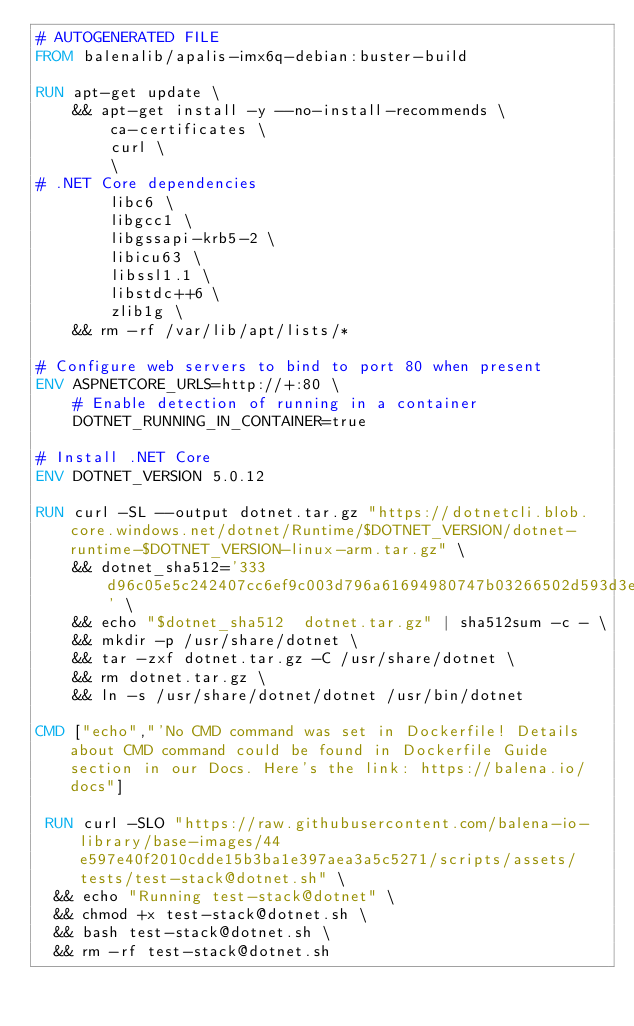Convert code to text. <code><loc_0><loc_0><loc_500><loc_500><_Dockerfile_># AUTOGENERATED FILE
FROM balenalib/apalis-imx6q-debian:buster-build

RUN apt-get update \
    && apt-get install -y --no-install-recommends \
        ca-certificates \
        curl \
        \
# .NET Core dependencies
        libc6 \
        libgcc1 \
        libgssapi-krb5-2 \
        libicu63 \
        libssl1.1 \
        libstdc++6 \
        zlib1g \
    && rm -rf /var/lib/apt/lists/*

# Configure web servers to bind to port 80 when present
ENV ASPNETCORE_URLS=http://+:80 \
    # Enable detection of running in a container
    DOTNET_RUNNING_IN_CONTAINER=true

# Install .NET Core
ENV DOTNET_VERSION 5.0.12

RUN curl -SL --output dotnet.tar.gz "https://dotnetcli.blob.core.windows.net/dotnet/Runtime/$DOTNET_VERSION/dotnet-runtime-$DOTNET_VERSION-linux-arm.tar.gz" \
    && dotnet_sha512='333d96c05e5c242407cc6ef9c003d796a61694980747b03266502d593d3e1c66d5e6147bfb41796df76ff0144617ee33c56afba740dd3eb4ea090a742b1c73d4' \
    && echo "$dotnet_sha512  dotnet.tar.gz" | sha512sum -c - \
    && mkdir -p /usr/share/dotnet \
    && tar -zxf dotnet.tar.gz -C /usr/share/dotnet \
    && rm dotnet.tar.gz \
    && ln -s /usr/share/dotnet/dotnet /usr/bin/dotnet

CMD ["echo","'No CMD command was set in Dockerfile! Details about CMD command could be found in Dockerfile Guide section in our Docs. Here's the link: https://balena.io/docs"]

 RUN curl -SLO "https://raw.githubusercontent.com/balena-io-library/base-images/44e597e40f2010cdde15b3ba1e397aea3a5c5271/scripts/assets/tests/test-stack@dotnet.sh" \
  && echo "Running test-stack@dotnet" \
  && chmod +x test-stack@dotnet.sh \
  && bash test-stack@dotnet.sh \
  && rm -rf test-stack@dotnet.sh 
</code> 